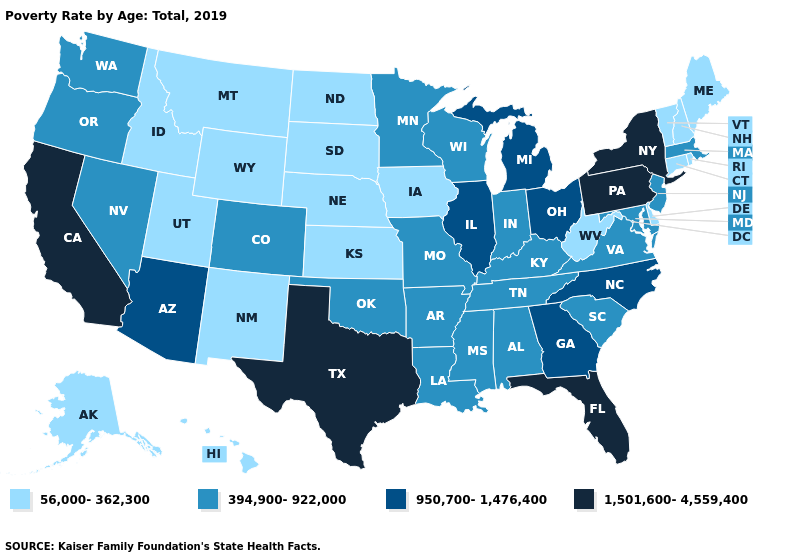What is the value of Pennsylvania?
Write a very short answer. 1,501,600-4,559,400. What is the value of California?
Keep it brief. 1,501,600-4,559,400. Name the states that have a value in the range 950,700-1,476,400?
Give a very brief answer. Arizona, Georgia, Illinois, Michigan, North Carolina, Ohio. What is the value of Indiana?
Be succinct. 394,900-922,000. Among the states that border Maryland , which have the highest value?
Be succinct. Pennsylvania. What is the value of Connecticut?
Be succinct. 56,000-362,300. What is the highest value in the Northeast ?
Give a very brief answer. 1,501,600-4,559,400. What is the value of Maine?
Short answer required. 56,000-362,300. What is the highest value in the South ?
Quick response, please. 1,501,600-4,559,400. Which states have the lowest value in the USA?
Write a very short answer. Alaska, Connecticut, Delaware, Hawaii, Idaho, Iowa, Kansas, Maine, Montana, Nebraska, New Hampshire, New Mexico, North Dakota, Rhode Island, South Dakota, Utah, Vermont, West Virginia, Wyoming. What is the value of Utah?
Write a very short answer. 56,000-362,300. Among the states that border Kentucky , does West Virginia have the lowest value?
Keep it brief. Yes. Which states have the highest value in the USA?
Write a very short answer. California, Florida, New York, Pennsylvania, Texas. Among the states that border Arkansas , does Texas have the highest value?
Keep it brief. Yes. Does Kansas have the same value as Mississippi?
Be succinct. No. 